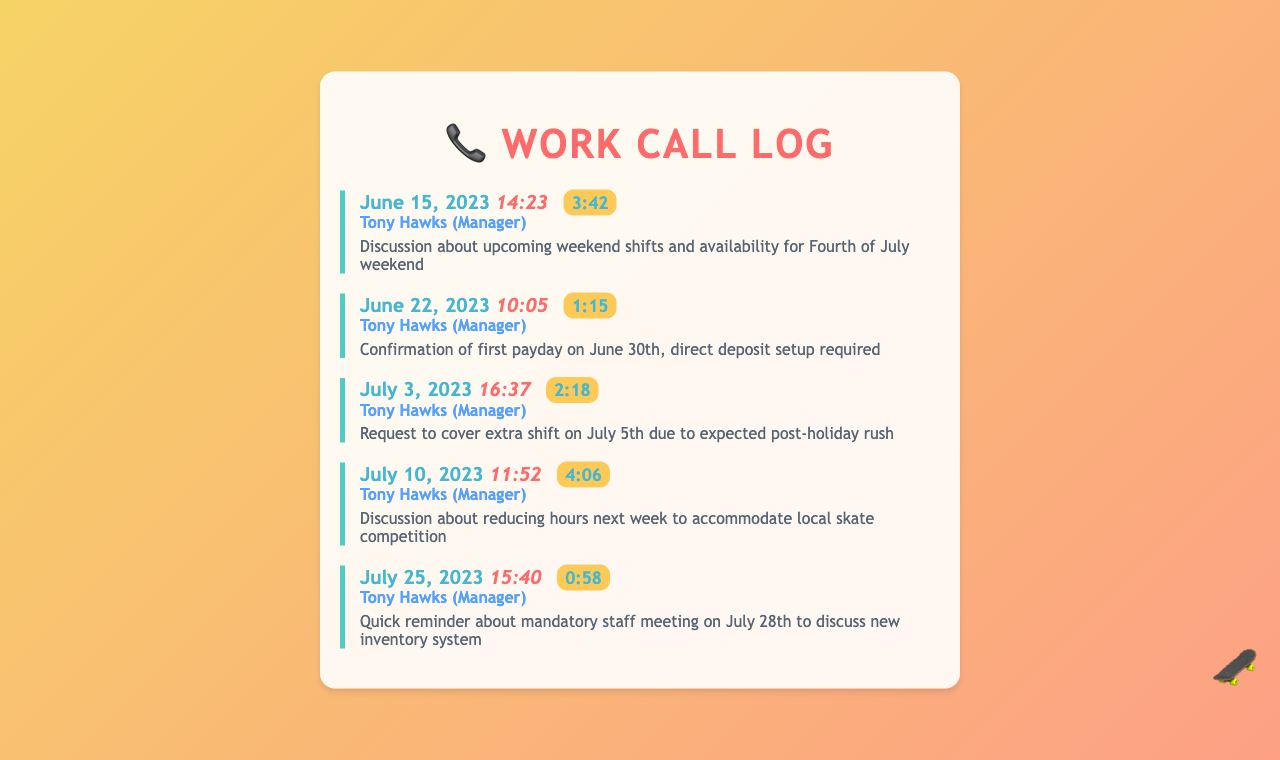what was discussed in the call on June 15, 2023? The call on June 15, 2023, was about upcoming weekend shifts and availability for the Fourth of July weekend.
Answer: weekend shifts who is the caller on July 3, 2023? The caller on July 3, 2023, is Tony Hawks, the manager.
Answer: Tony Hawks what is the duration of the call on June 22, 2023? The duration of the call on June 22, 2023, is 1 minute and 15 seconds.
Answer: 1:15 when is the first payday? The first payday is confirmed to be on June 30th.
Answer: June 30th what was the reason for the call on July 10, 2023? The call on July 10, 2023, was to discuss reducing hours next week to accommodate a local skate competition.
Answer: reducing hours how many calls were made by the manager in total? There are five records of calls made by the manager in the document.
Answer: five what is the main topic of the call on July 25, 2023? The main topic of the call on July 25, 2023, was a reminder about a mandatory staff meeting.
Answer: mandatory staff meeting which date was the call about direct deposit setup? The call about direct deposit setup was on June 22, 2023.
Answer: June 22, 2023 what was the time of the call on July 25, 2023? The time of the call on July 25, 2023, is 15:40.
Answer: 15:40 